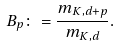<formula> <loc_0><loc_0><loc_500><loc_500>B _ { p } \colon = \frac { m _ { K , d + p } } { m _ { K , d } } .</formula> 